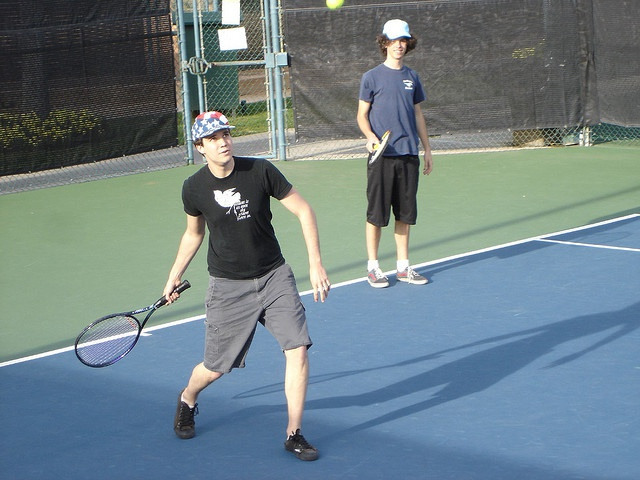Describe the objects in this image and their specific colors. I can see people in black, darkgray, beige, and gray tones, people in black, gray, and ivory tones, tennis racket in black, darkgray, gray, and white tones, tennis racket in black, ivory, gray, darkgray, and khaki tones, and sports ball in black, khaki, olive, and lightyellow tones in this image. 